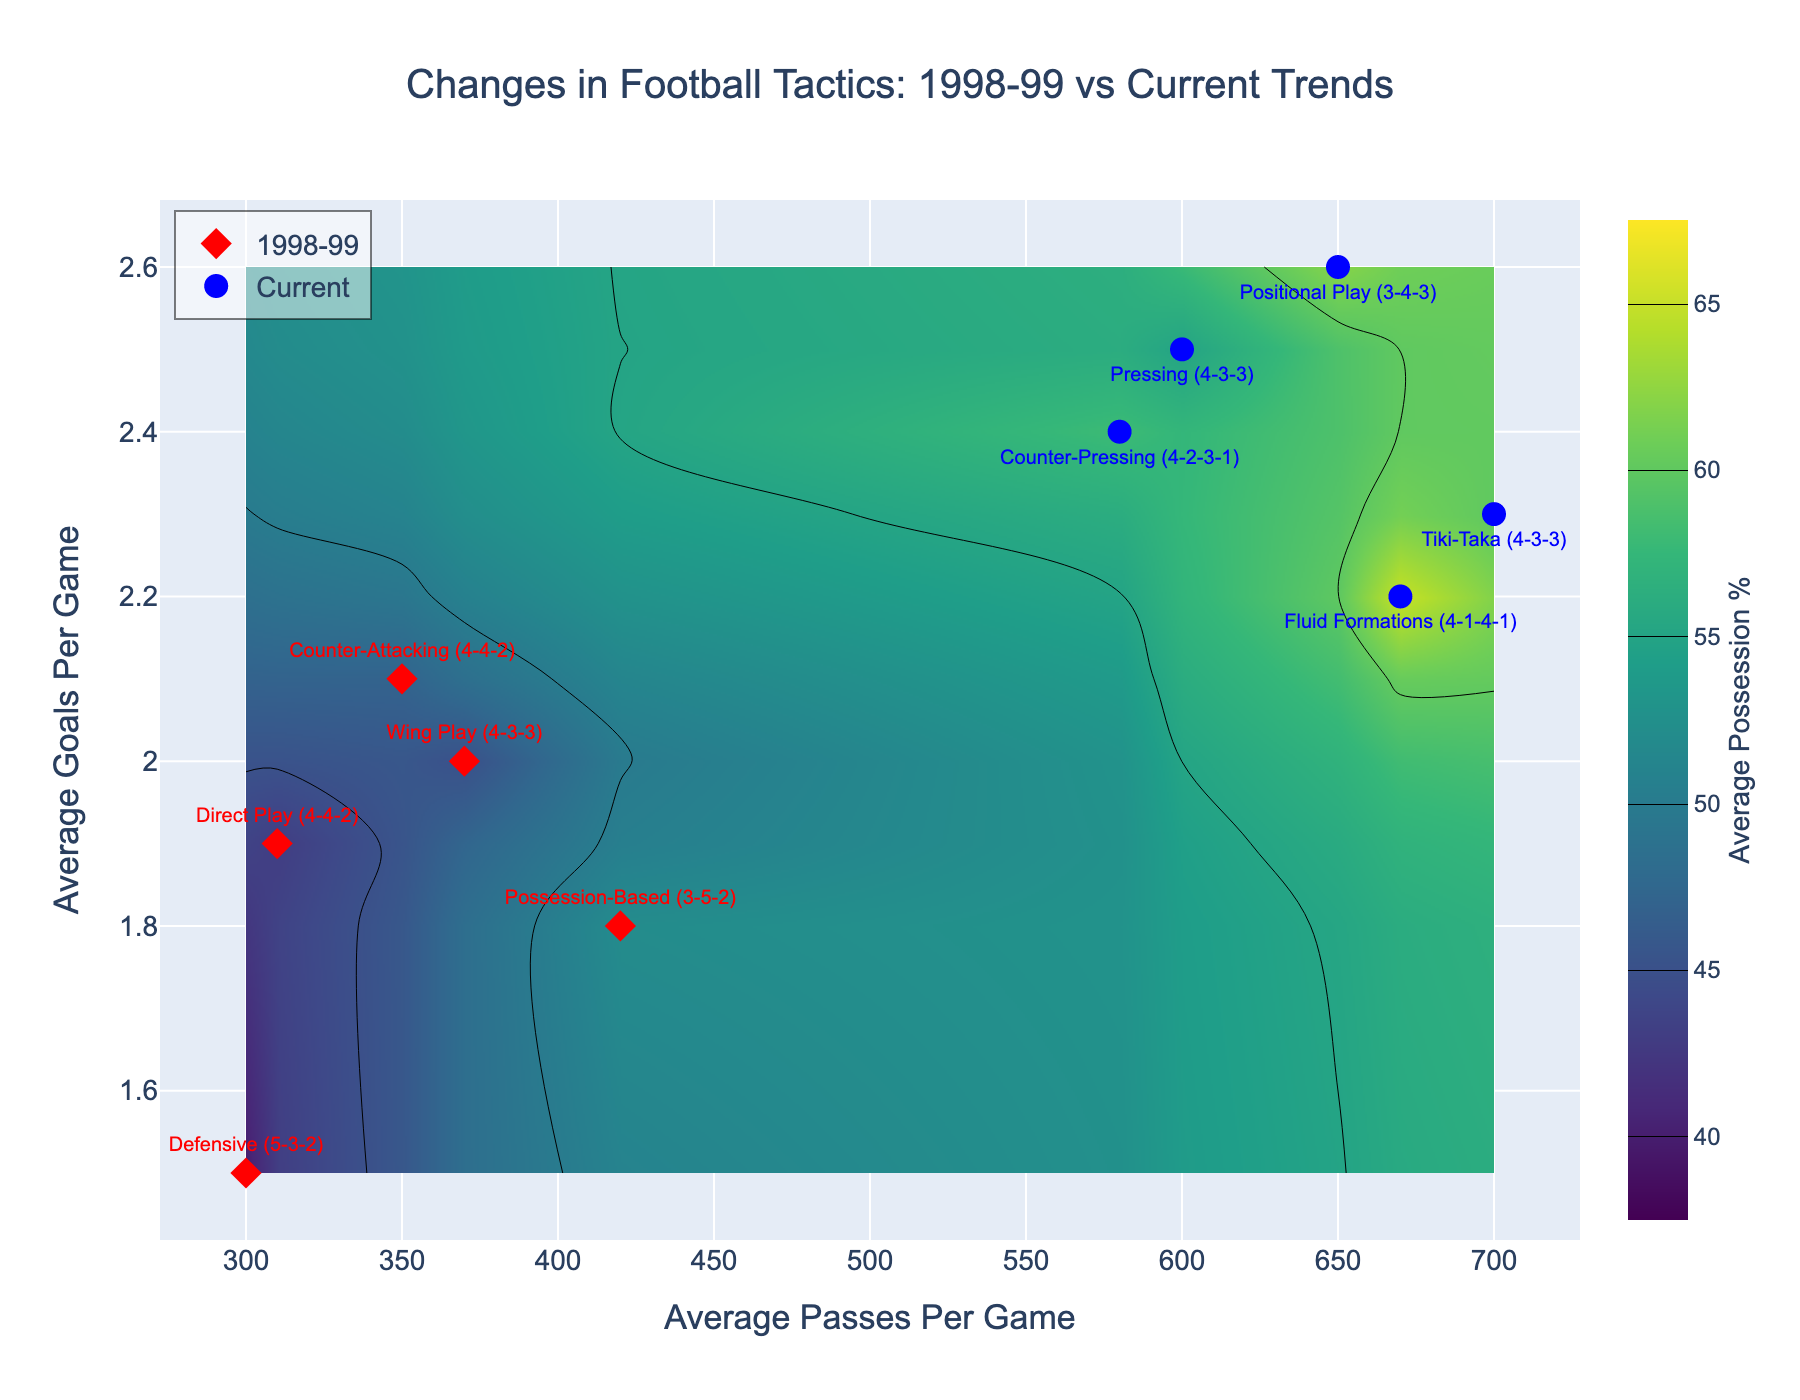What is the title of the figure? The title of the figure is prominently displayed at the top, and it reads "Changes in Football Tactics: 1998-99 vs Current Trends".
Answer: Changes in Football Tactics: 1998-99 vs Current Trends How many data points are there for each year? Count the number of data points (red and blue markers) for 1998-99 and Current. Five red markers represent 1998-99 data points and five blue markers represent current data points.
Answer: 5 for each year Which tactic in 1998-99 had the highest average goals per game? Look for the red markers (1998-99) and check the label with the highest y-axis value (Average Goals Per Game). The "Counter-Attacking (4-4-2)" tactic has the highest average goals per game at 2.1.
Answer: Counter-Attacking (4-4-2) What is the range of average possession percentages shown in the color scale? The color scale on the right shows the range for Average Possession Percentage. It starts at 40 and ends at 65.
Answer: 40 to 65 How does the average possession percentage compare between 1998-99 tactics and current tactics generally? Observe the color around the red markers (1998-99) and blue markers (Current). The colors around current tactics are generally in the higher range of the color scale (~55-65), while the 1998-99 tactics are mostly in the lower range (~40-52).
Answer: Current tactics have generally higher possession percentages Which year has a tactic with an average of over 600 passes per game? Look at the x-axis (Average Passes Per Game) and find markers to the right of 600. The blue markers representing Current years indicate tactics such as "Pressing (4-3-3)", "Tiki-Taka (4-3-3)", "Positional Play (3-4-3)", and "Fluid Formations (4-1-4-1)" with over 600 passes per game.
Answer: Current What is the difference in average passes per game between the "Defensive (5-3-2)" tactic in 1998-99 and the "Positional Play (3-4-3)" tactic currently? Locate the markers: the average passes per game for "Defensive (5-3-2)" in 1998-99 is 300, and for "Positional Play (3-4-3)" currently is 650. Subtract 300 from 650 to get the difference.
Answer: 350 Which tactic in 'Current' has the highest average possession percentage, and what is its value? Check the labels and colors of blue markers (Current). "Fluid Formations (4-1-4-1)" has the highest average possession percentage, indicated by 65 on the color scale.
Answer: Fluid Formations (4-1-4-1), 65 Are there any tactics from either year that have the same formation but different tactics? Compare the formations listed in the labels for both years. Both "Counter-Attacking (4-4-2)" in 1998-99 and "Direct Play (4-4-2)" in 1998-99 share the same formation.
Answer: Yes, Counter-Attacking (4-4-2) and Direct Play (4-4-2) in 1998-99 